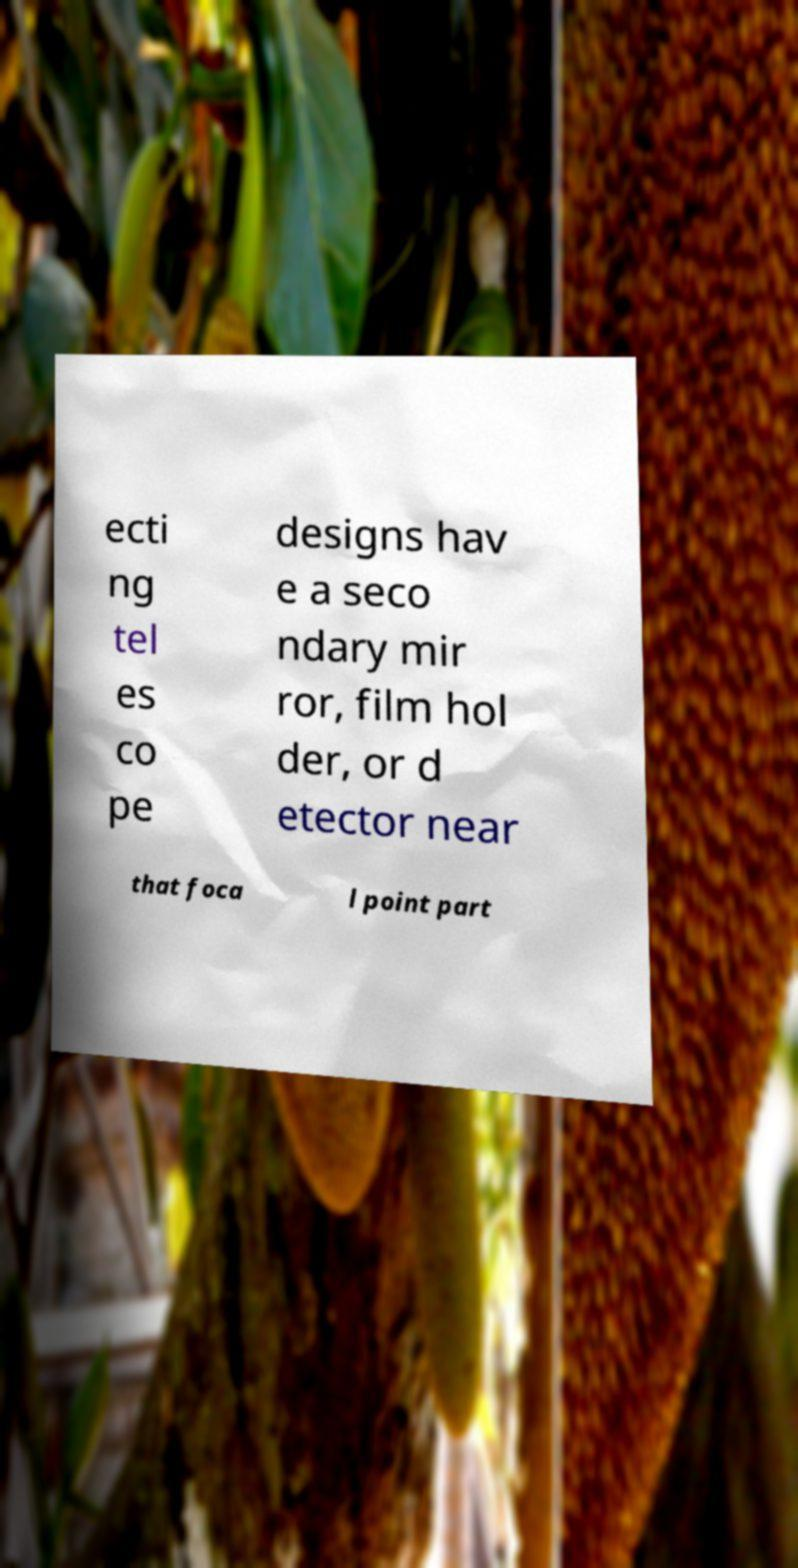For documentation purposes, I need the text within this image transcribed. Could you provide that? ecti ng tel es co pe designs hav e a seco ndary mir ror, film hol der, or d etector near that foca l point part 